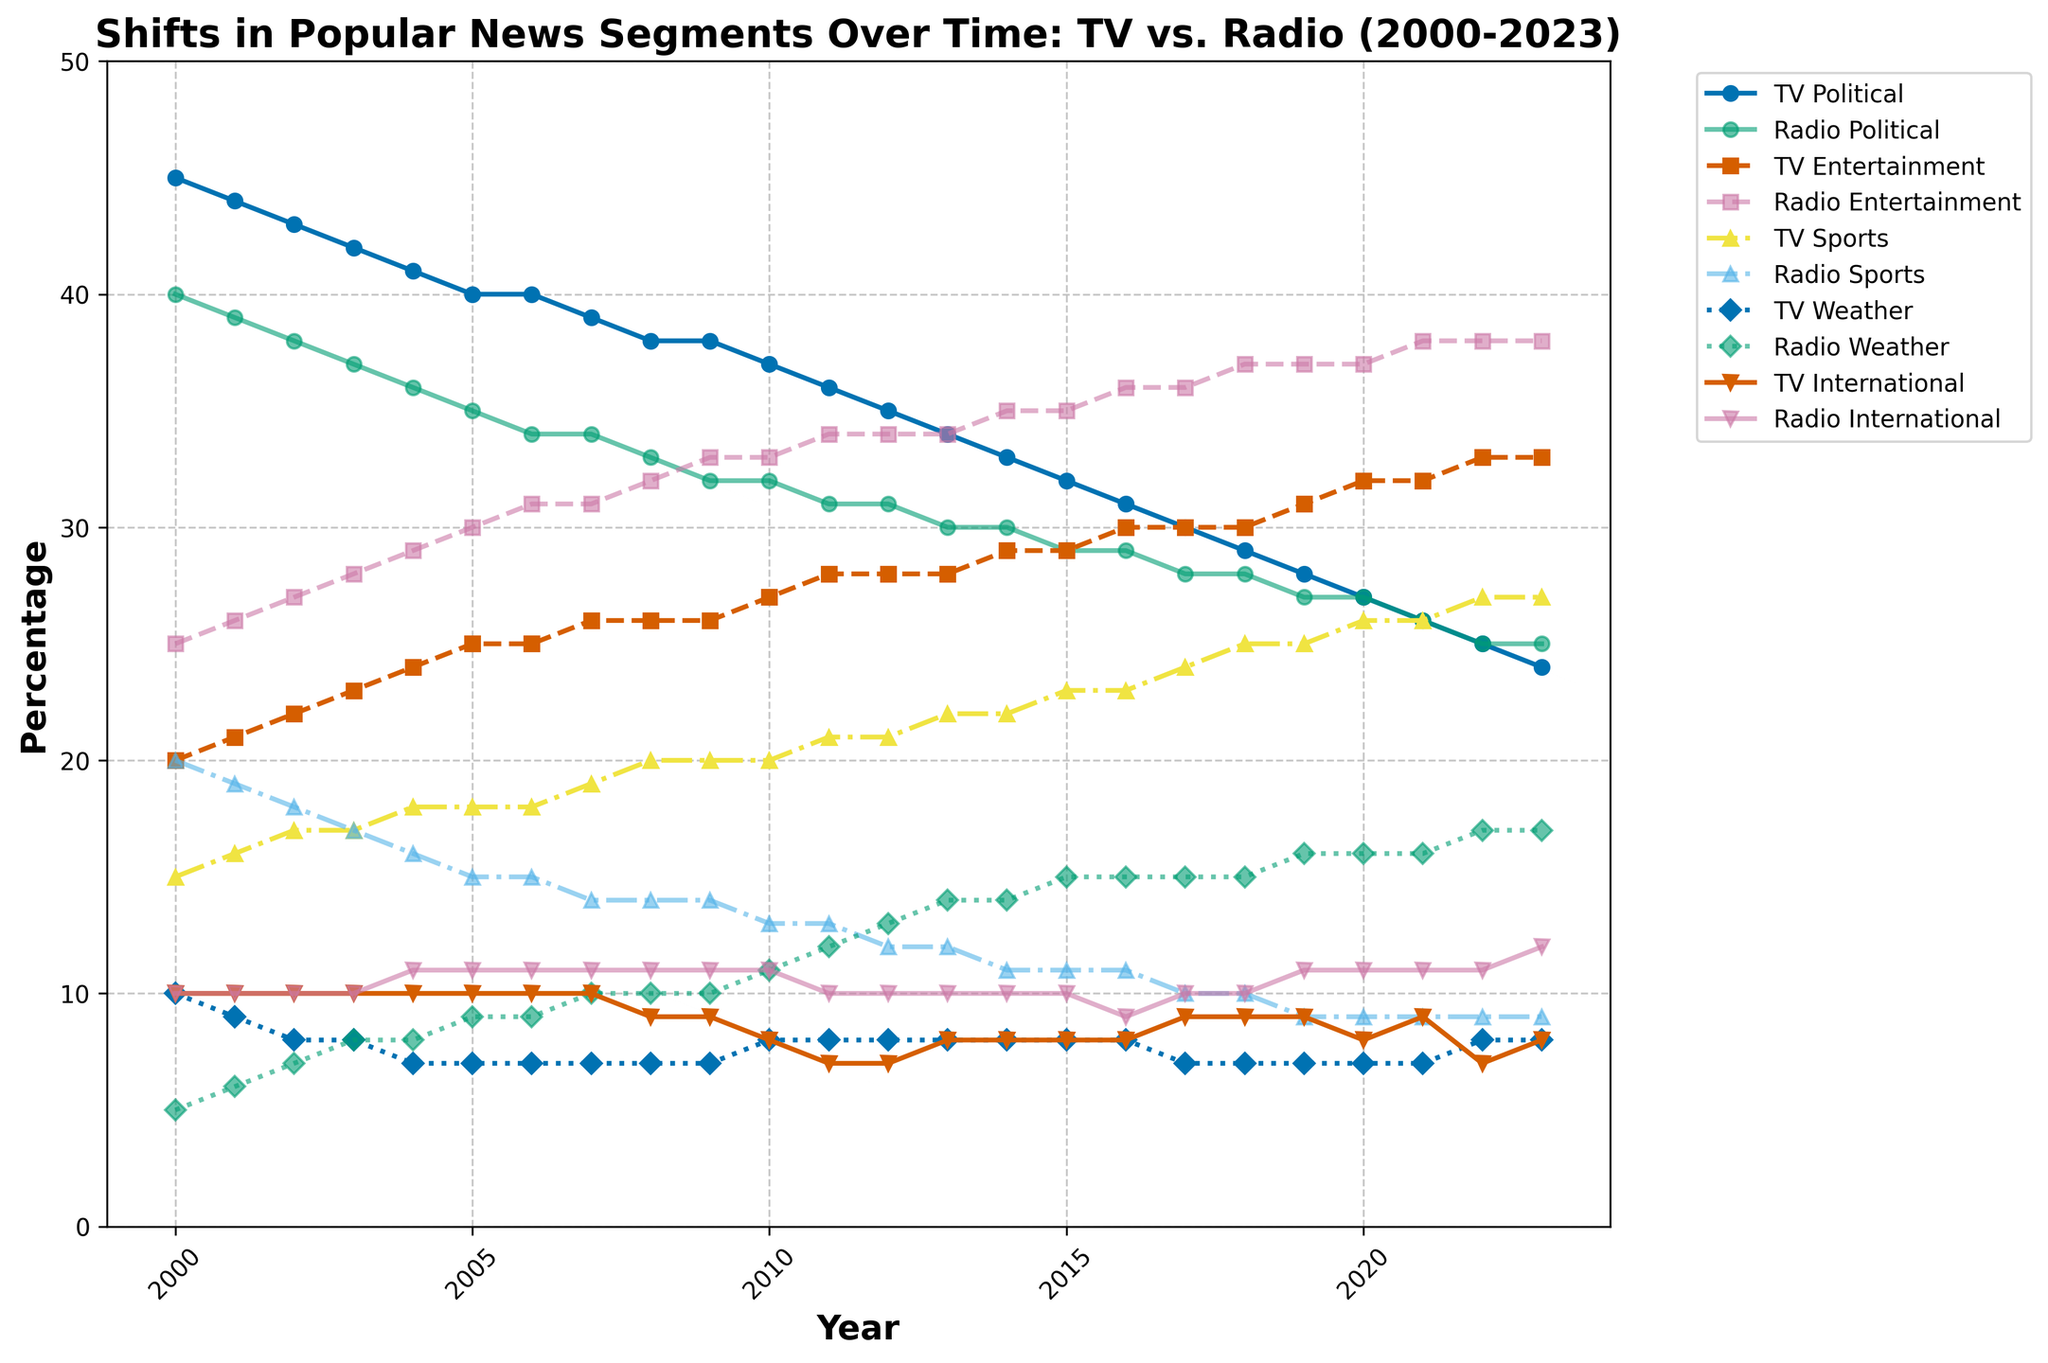What is the title of the figure? The title of the figure is displayed at the top, and it reads "Shifts in Popular News Segments Over Time: TV vs. Radio (2000-2023)."
Answer: Shifts in Popular News Segments Over Time: TV vs. Radio (2000-2023) Which news segment on TV had the highest percentage in 2000? By looking at the lines and their labels for the year 2000, the TV Political News segment was the highest at 45%.
Answer: TV Political News Between 2000 and 2023, did TV Weather News or Radio Weather News see a larger increase? Comparing the starting and ending values for both segments: TV Weather News started at 10% and ended at 8%, while Radio Weather News started at 5% and ended at 17%. Radio Weather News saw a larger increase.
Answer: Radio Weather News In what year did TV Entertainment News surpass TV Political News in popularity? By observing the intersection of the lines for TV Political News and TV Entertainment News, TV Entertainment News surpassed TV Political News around 2020.
Answer: 2020 Which segment had the largest drop in popularity on TV between 2000 and 2023? Assessing the slopes of the lines representing TV news segments, TV Political News declined from 45% to 24%, which is the largest drop.
Answer: TV Political News On average, how much did Radio International News change every year from 2000 to 2023? From 2000 to 2023 is a span of 23 years, with Radio International News rising from 10% to 12%. The average yearly change is (12-10) / 23 ≈ 0.09%.
Answer: 0.09% per year What are the trends for TV Sports News from 2000 to 2023? The line for TV Sports News shows a general increasing trend, starting at 15% in 2000 and reaching 27% by 2023.
Answer: Increasing By 2023, which segment is more popular on TV and radio, Entertainment News or Sports News? By comparing the values in 2023 for both segments on TV and radio: TV Entertainment News (33%) vs. TV Sports News (27%), and Radio Entertainment News (38%) vs. Radio Sports News (9%). Entertainment News is more popular on both TV and radio.
Answer: Entertainment News Between 2005 and 2015, how did the percentage of Radio Political News change? By looking at the values in 2005 (35%) and 2015 (29%), Radio Political News decreased by 6 percentage points over this period.
Answer: Decreased by 6% Which news segment on Radio had the least variation over the years? Observing the lines for radio segments, Radio International News remained relatively stable, ending at 12% in 2023, while starting at 10% in 2000, showing minimal variation.
Answer: Radio International News 